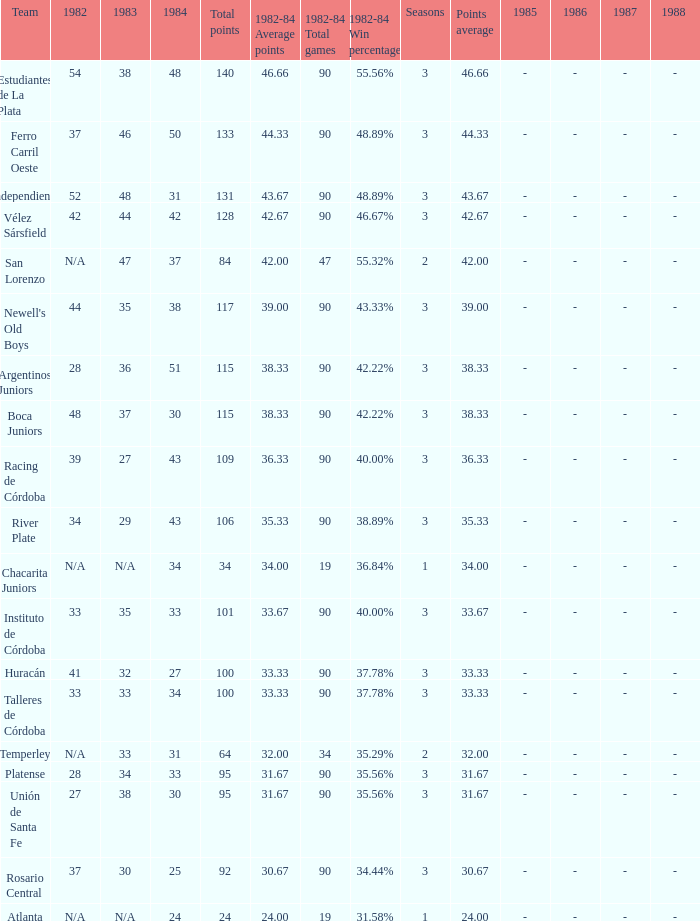What is the number of seasons for the team with a total fewer than 24? None. 